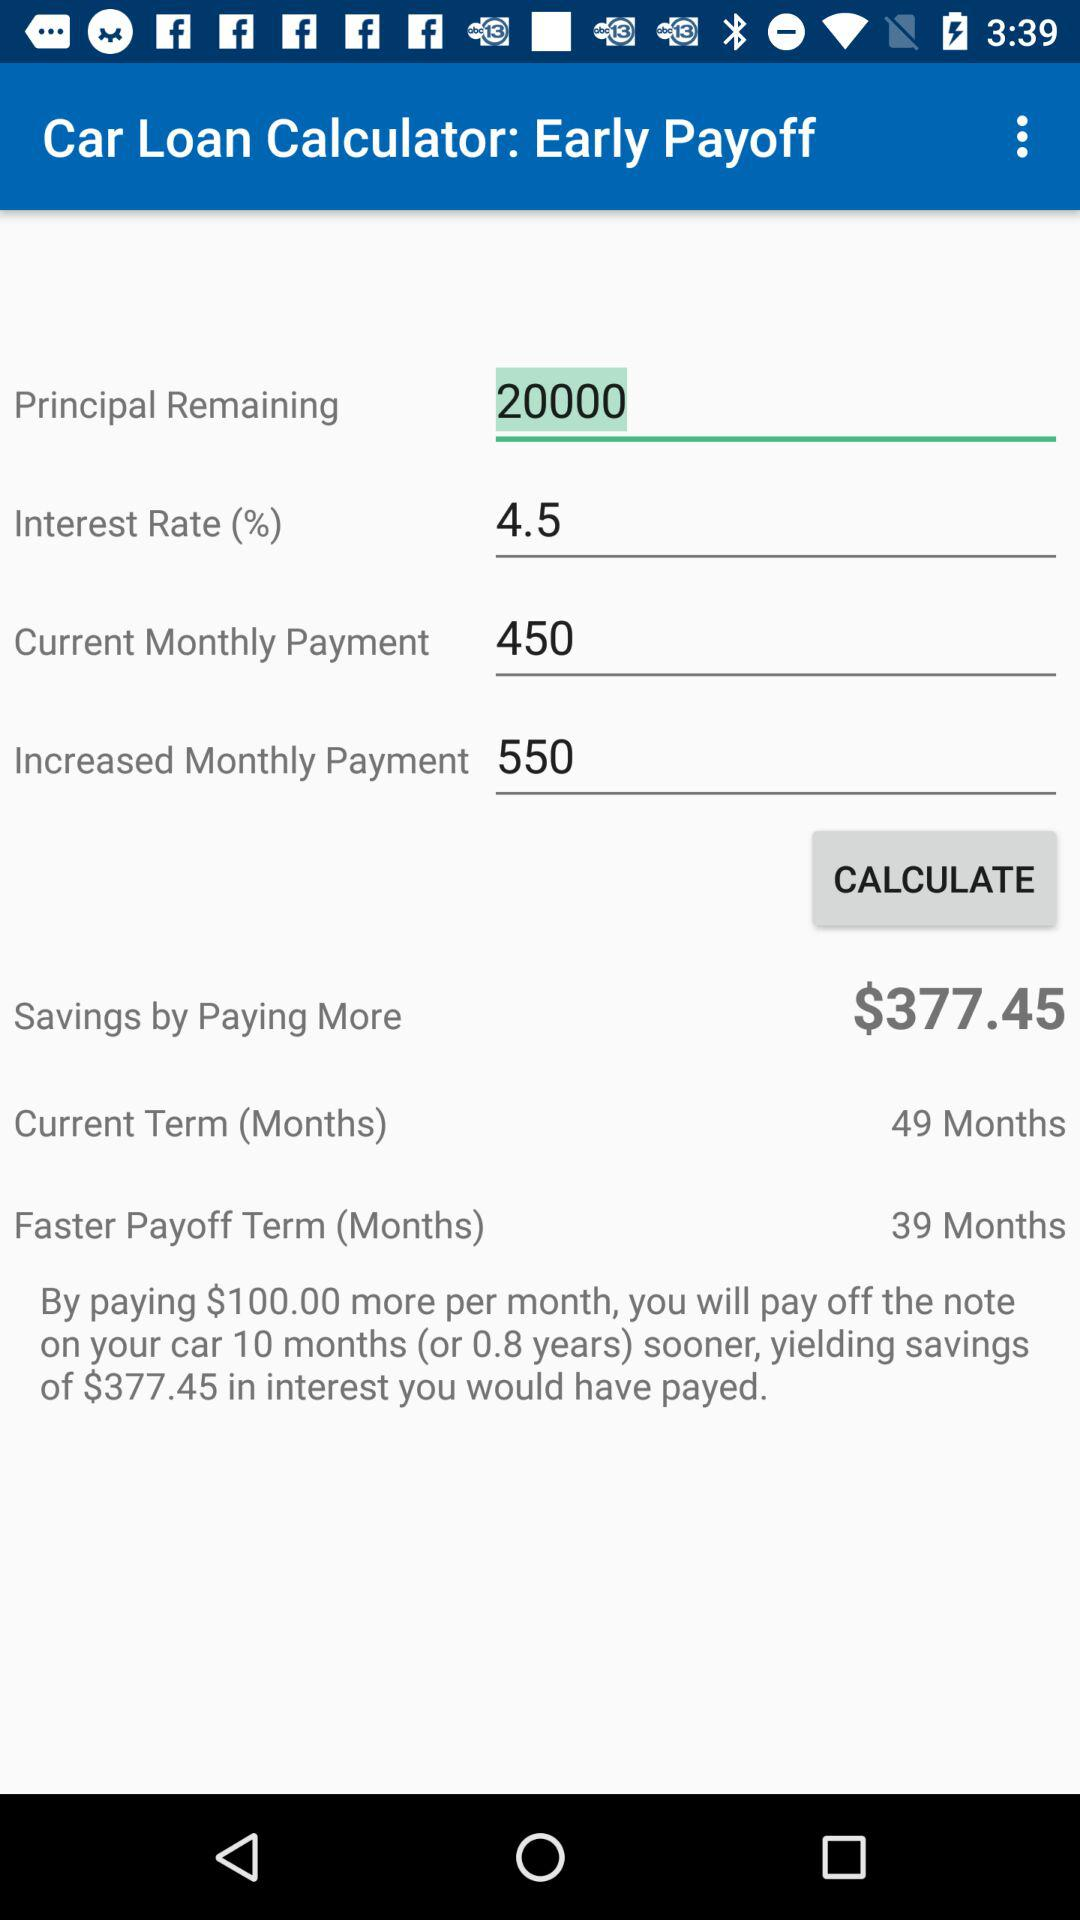How much interest will I save by paying $100 more per month?
Answer the question using a single word or phrase. $377.45 